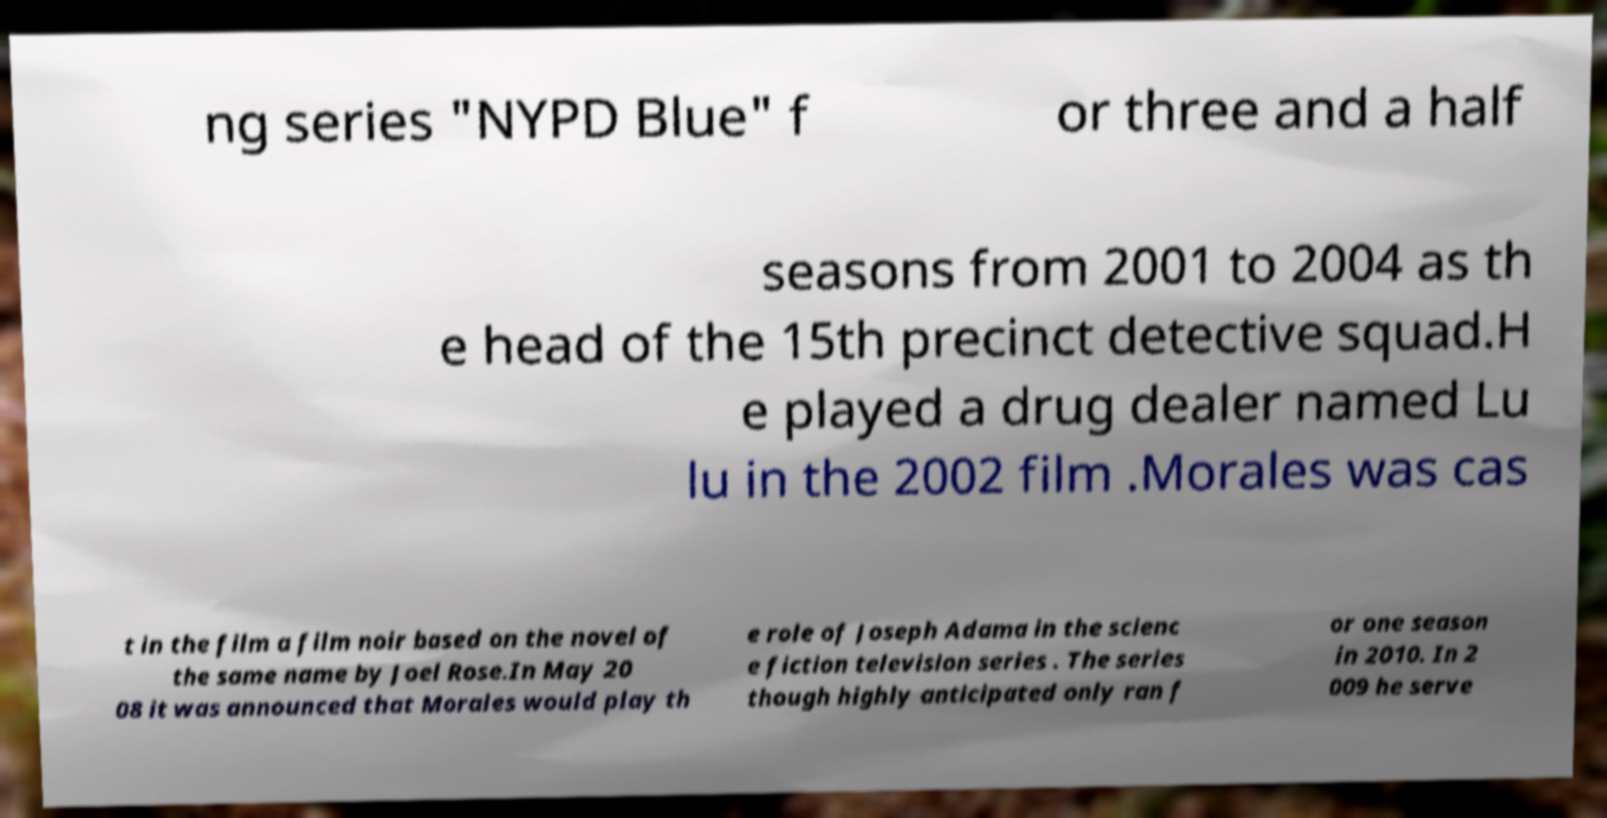Could you extract and type out the text from this image? ng series "NYPD Blue" f or three and a half seasons from 2001 to 2004 as th e head of the 15th precinct detective squad.H e played a drug dealer named Lu lu in the 2002 film .Morales was cas t in the film a film noir based on the novel of the same name by Joel Rose.In May 20 08 it was announced that Morales would play th e role of Joseph Adama in the scienc e fiction television series . The series though highly anticipated only ran f or one season in 2010. In 2 009 he serve 